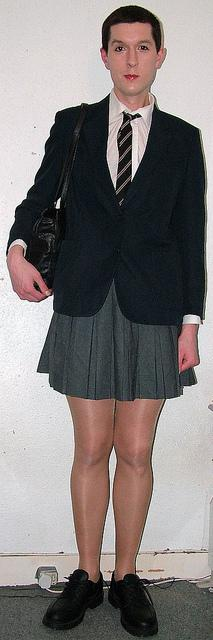What kind of uniform is worn by the man in this picture?

Choices:
A) police
B) school
C) cheerleader
D) football school 